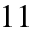Convert formula to latex. <formula><loc_0><loc_0><loc_500><loc_500>1 1</formula> 